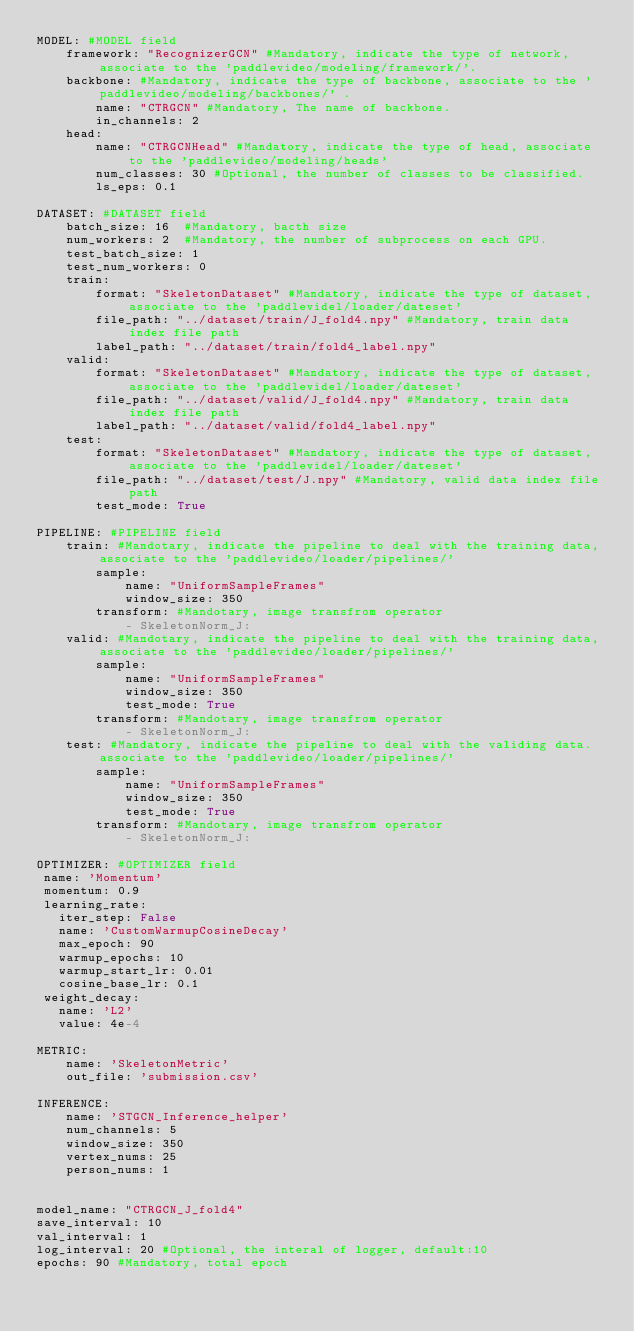Convert code to text. <code><loc_0><loc_0><loc_500><loc_500><_YAML_>MODEL: #MODEL field
    framework: "RecognizerGCN" #Mandatory, indicate the type of network, associate to the 'paddlevideo/modeling/framework/'.
    backbone: #Mandatory, indicate the type of backbone, associate to the 'paddlevideo/modeling/backbones/' .
        name: "CTRGCN" #Mandatory, The name of backbone.
        in_channels: 2
    head:
        name: "CTRGCNHead" #Mandatory, indicate the type of head, associate to the 'paddlevideo/modeling/heads'
        num_classes: 30 #Optional, the number of classes to be classified.
        ls_eps: 0.1

DATASET: #DATASET field
    batch_size: 16  #Mandatory, bacth size
    num_workers: 2  #Mandatory, the number of subprocess on each GPU.
    test_batch_size: 1
    test_num_workers: 0
    train:
        format: "SkeletonDataset" #Mandatory, indicate the type of dataset, associate to the 'paddlevidel/loader/dateset'
        file_path: "../dataset/train/J_fold4.npy" #Mandatory, train data index file path
        label_path: "../dataset/train/fold4_label.npy"
    valid:
        format: "SkeletonDataset" #Mandatory, indicate the type of dataset, associate to the 'paddlevidel/loader/dateset'
        file_path: "../dataset/valid/J_fold4.npy" #Mandatory, train data index file path
        label_path: "../dataset/valid/fold4_label.npy"
    test:
        format: "SkeletonDataset" #Mandatory, indicate the type of dataset, associate to the 'paddlevidel/loader/dateset'
        file_path: "../dataset/test/J.npy" #Mandatory, valid data index file path
        test_mode: True

PIPELINE: #PIPELINE field
    train: #Mandotary, indicate the pipeline to deal with the training data, associate to the 'paddlevideo/loader/pipelines/'
        sample:
            name: "UniformSampleFrames"
            window_size: 350
        transform: #Mandotary, image transfrom operator
            - SkeletonNorm_J:
    valid: #Mandotary, indicate the pipeline to deal with the training data, associate to the 'paddlevideo/loader/pipelines/'
        sample:
            name: "UniformSampleFrames"
            window_size: 350
            test_mode: True
        transform: #Mandotary, image transfrom operator
            - SkeletonNorm_J:
    test: #Mandatory, indicate the pipeline to deal with the validing data. associate to the 'paddlevideo/loader/pipelines/'
        sample:
            name: "UniformSampleFrames"
            window_size: 350
            test_mode: True
        transform: #Mandotary, image transfrom operator
            - SkeletonNorm_J:

OPTIMIZER: #OPTIMIZER field
 name: 'Momentum'
 momentum: 0.9
 learning_rate:
   iter_step: False
   name: 'CustomWarmupCosineDecay'
   max_epoch: 90
   warmup_epochs: 10
   warmup_start_lr: 0.01
   cosine_base_lr: 0.1
 weight_decay:
   name: 'L2'
   value: 4e-4

METRIC:
    name: 'SkeletonMetric'
    out_file: 'submission.csv'

INFERENCE:
    name: 'STGCN_Inference_helper'
    num_channels: 5
    window_size: 350
    vertex_nums: 25
    person_nums: 1


model_name: "CTRGCN_J_fold4"
save_interval: 10
val_interval: 1
log_interval: 20 #Optional, the interal of logger, default:10
epochs: 90 #Mandatory, total epoch
</code> 